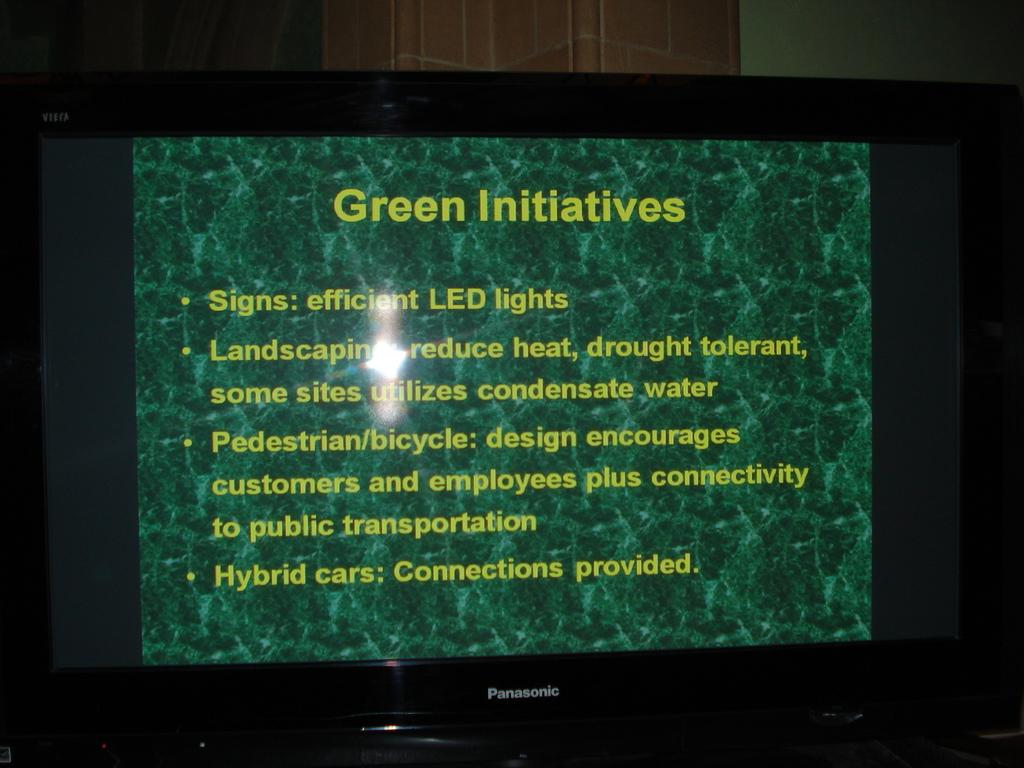<image>
Render a clear and concise summary of the photo. A screen displays several bullet points of the Green Initiative, including Signs: Efficient LED lights and Hybrid Cars: Connections provided. 